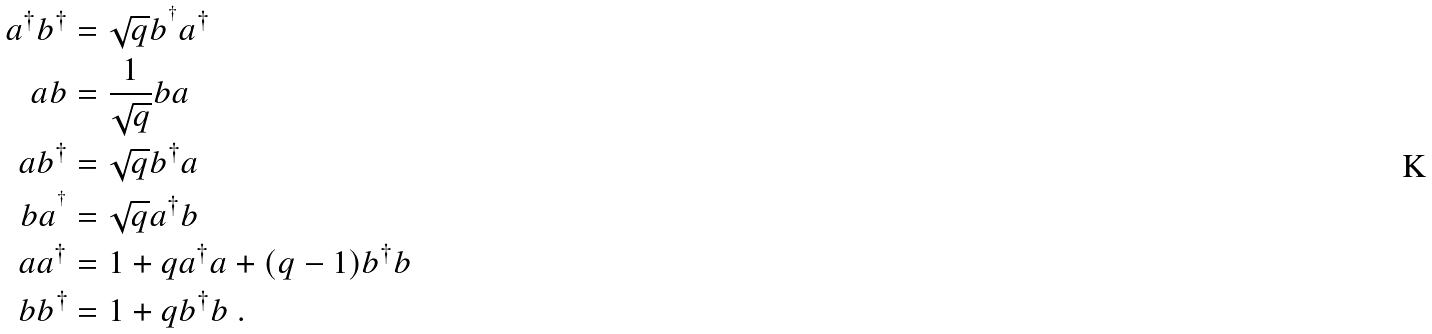<formula> <loc_0><loc_0><loc_500><loc_500>a ^ { \dagger } b ^ { \dagger } & = \sqrt { q } b ^ { ^ { \dagger } } a ^ { \dagger } \\ a b & = \frac { 1 } { \sqrt { q } } b a \\ a b ^ { \dagger } & = \sqrt { q } b ^ { \dagger } a \\ b a ^ { ^ { \dagger } } & = \sqrt { q } a ^ { \dagger } b \\ a a ^ { \dagger } & = 1 + q a ^ { \dagger } a + ( q - 1 ) b ^ { \dagger } b \\ b b ^ { \dagger } & = 1 + q b ^ { \dagger } b \text { .}</formula> 